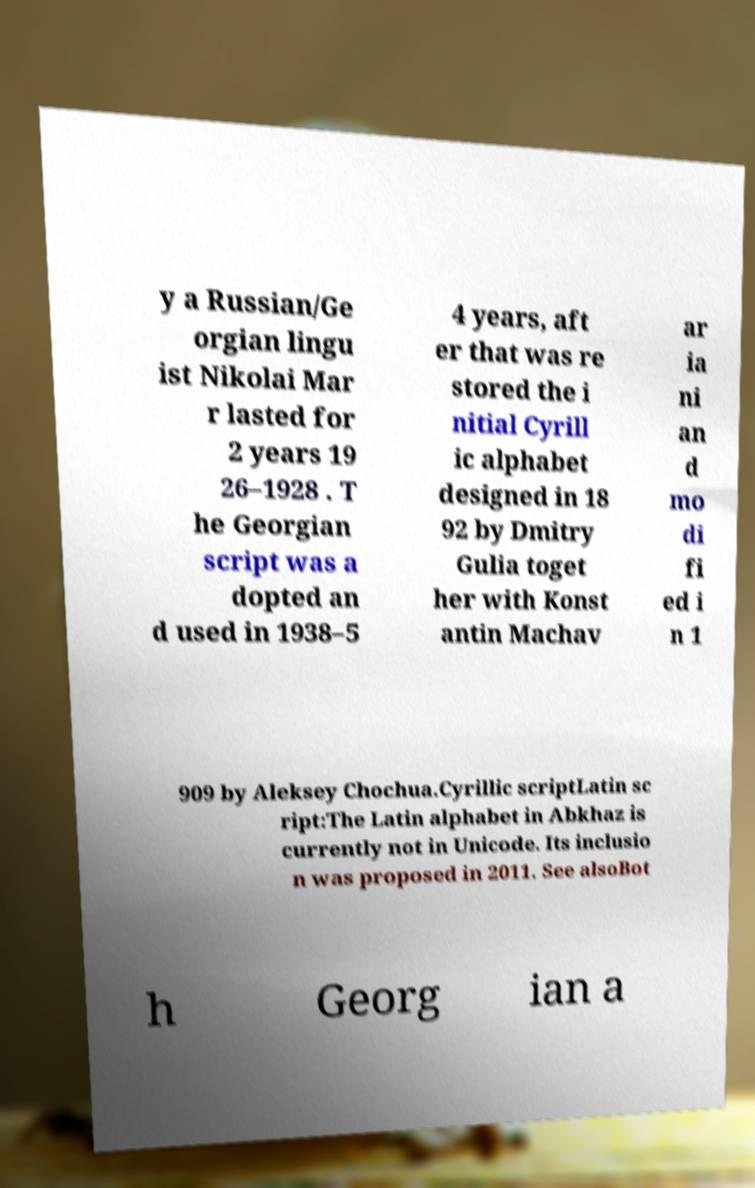Could you extract and type out the text from this image? y a Russian/Ge orgian lingu ist Nikolai Mar r lasted for 2 years 19 26–1928 . T he Georgian script was a dopted an d used in 1938–5 4 years, aft er that was re stored the i nitial Cyrill ic alphabet designed in 18 92 by Dmitry Gulia toget her with Konst antin Machav ar ia ni an d mo di fi ed i n 1 909 by Aleksey Chochua.Cyrillic scriptLatin sc ript:The Latin alphabet in Abkhaz is currently not in Unicode. Its inclusio n was proposed in 2011. See alsoBot h Georg ian a 